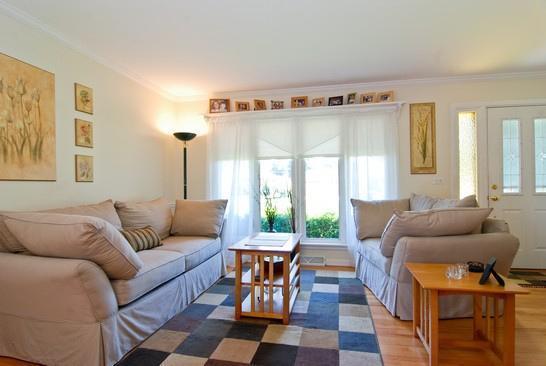How many picture frames are above the window?
Give a very brief answer. 10. How many couches can you see?
Give a very brief answer. 2. 